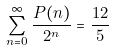<formula> <loc_0><loc_0><loc_500><loc_500>\sum _ { n = 0 } ^ { \infty } \frac { P ( n ) } { 2 ^ { n } } = \frac { 1 2 } { 5 }</formula> 